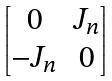Convert formula to latex. <formula><loc_0><loc_0><loc_500><loc_500>\begin{bmatrix} 0 & J _ { n } \\ - J _ { n } & 0 \end{bmatrix}</formula> 